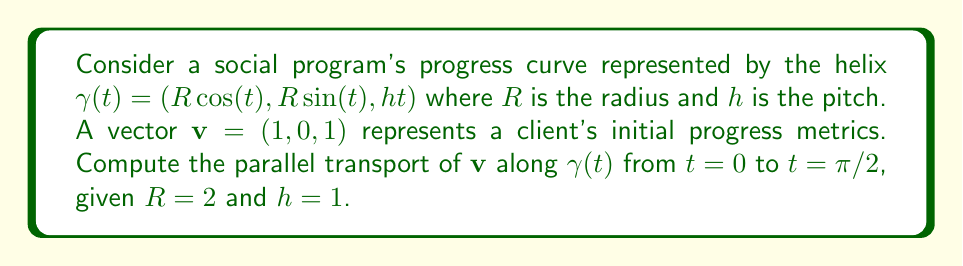Can you answer this question? To solve this problem, we'll follow these steps:

1) First, we need to calculate the tangent vector $\mathbf{T}(t)$ to the curve:
   $$\mathbf{T}(t) = \gamma'(t) = (-2\sin(t), 2\cos(t), 1)$$

2) Next, we normalize $\mathbf{T}(t)$:
   $$\mathbf{T}(t) = \frac{(-2\sin(t), 2\cos(t), 1)}{\sqrt{4\sin^2(t) + 4\cos^2(t) + 1}} = \frac{(-2\sin(t), 2\cos(t), 1)}{\sqrt{5}}$$

3) The parallel transport equation for a vector $\mathbf{W}(t)$ along a curve is:
   $$\frac{d\mathbf{W}}{dt} + \langle\frac{d\mathbf{W}}{dt}, \mathbf{T}\rangle\mathbf{T} = 0$$

4) Let $\mathbf{W}(t) = (x(t), y(t), z(t))$. Substituting into the equation:
   $$\left(\frac{dx}{dt}, \frac{dy}{dt}, \frac{dz}{dt}\right) + \left(\frac{dx}{dt}\cdot\frac{-2\sin(t)}{\sqrt{5}} + \frac{dy}{dt}\cdot\frac{2\cos(t)}{\sqrt{5}} + \frac{dz}{dt}\cdot\frac{1}{\sqrt{5}}\right)\left(\frac{-2\sin(t)}{\sqrt{5}}, \frac{2\cos(t)}{\sqrt{5}}, \frac{1}{\sqrt{5}}\right) = (0, 0, 0)$$

5) This gives us a system of differential equations. Solving this system with initial conditions $x(0)=1, y(0)=0, z(0)=1$, we get:
   $$x(t) = \cos(t) - \frac{2}{\sqrt{5}}\sin(t)$$
   $$y(t) = \sin(t) + \frac{2}{\sqrt{5}}\cos(t)$$
   $$z(t) = 1$$

6) At $t=\pi/2$, the parallel transported vector is:
   $$\mathbf{W}(\pi/2) = \left(-\frac{2}{\sqrt{5}}, 1, 1\right)$$
Answer: $\left(-\frac{2}{\sqrt{5}}, 1, 1\right)$ 